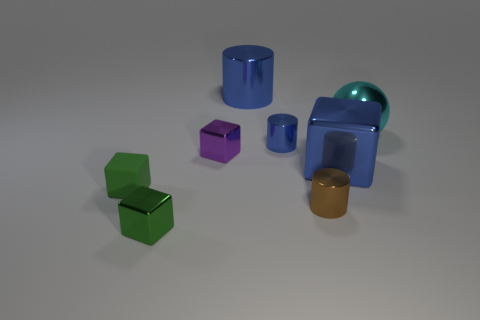Subtract all cyan blocks. Subtract all cyan cylinders. How many blocks are left? 4 Add 2 tiny green metallic cylinders. How many objects exist? 10 Subtract all spheres. How many objects are left? 7 Subtract 0 cyan cylinders. How many objects are left? 8 Subtract all cyan shiny blocks. Subtract all small brown metal cylinders. How many objects are left? 7 Add 6 big cyan balls. How many big cyan balls are left? 7 Add 7 purple shiny cubes. How many purple shiny cubes exist? 8 